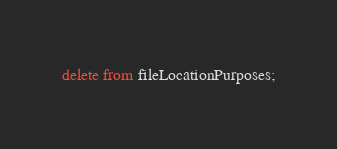Convert code to text. <code><loc_0><loc_0><loc_500><loc_500><_SQL_>delete from fileLocationPurposes;
</code> 